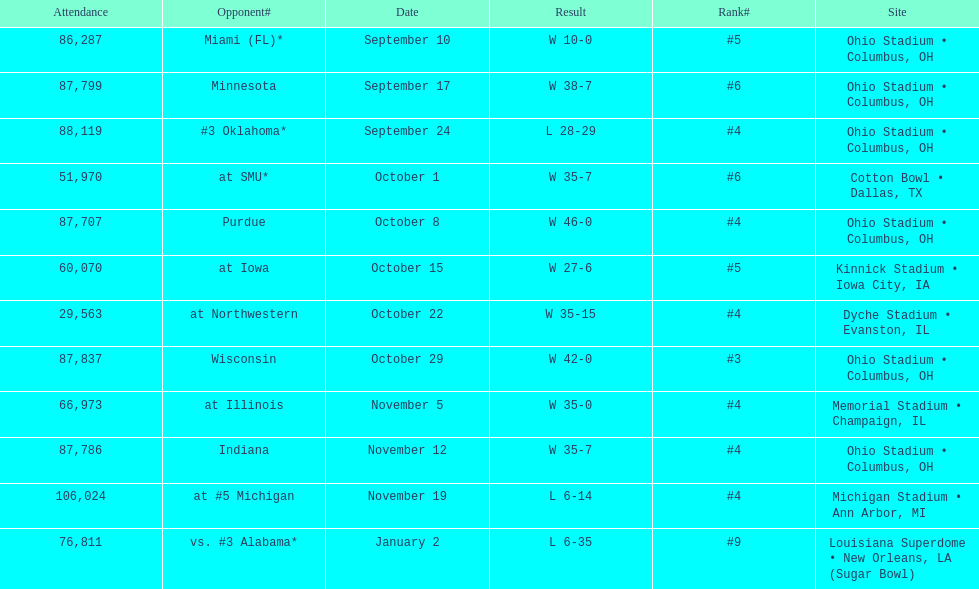Write the full table. {'header': ['Attendance', 'Opponent#', 'Date', 'Result', 'Rank#', 'Site'], 'rows': [['86,287', 'Miami (FL)*', 'September 10', 'W\xa010-0', '#5', 'Ohio Stadium • Columbus, OH'], ['87,799', 'Minnesota', 'September 17', 'W\xa038-7', '#6', 'Ohio Stadium • Columbus, OH'], ['88,119', '#3\xa0Oklahoma*', 'September 24', 'L\xa028-29', '#4', 'Ohio Stadium • Columbus, OH'], ['51,970', 'at\xa0SMU*', 'October 1', 'W\xa035-7', '#6', 'Cotton Bowl • Dallas, TX'], ['87,707', 'Purdue', 'October 8', 'W\xa046-0', '#4', 'Ohio Stadium • Columbus, OH'], ['60,070', 'at\xa0Iowa', 'October 15', 'W\xa027-6', '#5', 'Kinnick Stadium • Iowa City, IA'], ['29,563', 'at\xa0Northwestern', 'October 22', 'W\xa035-15', '#4', 'Dyche Stadium • Evanston, IL'], ['87,837', 'Wisconsin', 'October 29', 'W\xa042-0', '#3', 'Ohio Stadium • Columbus, OH'], ['66,973', 'at\xa0Illinois', 'November 5', 'W\xa035-0', '#4', 'Memorial Stadium • Champaign, IL'], ['87,786', 'Indiana', 'November 12', 'W\xa035-7', '#4', 'Ohio Stadium • Columbus, OH'], ['106,024', 'at\xa0#5\xa0Michigan', 'November 19', 'L\xa06-14', '#4', 'Michigan Stadium • Ann Arbor, MI'], ['76,811', 'vs.\xa0#3\xa0Alabama*', 'January 2', 'L\xa06-35', '#9', 'Louisiana Superdome • New Orleans, LA (Sugar Bowl)']]} How many dates are on the chart 12. 